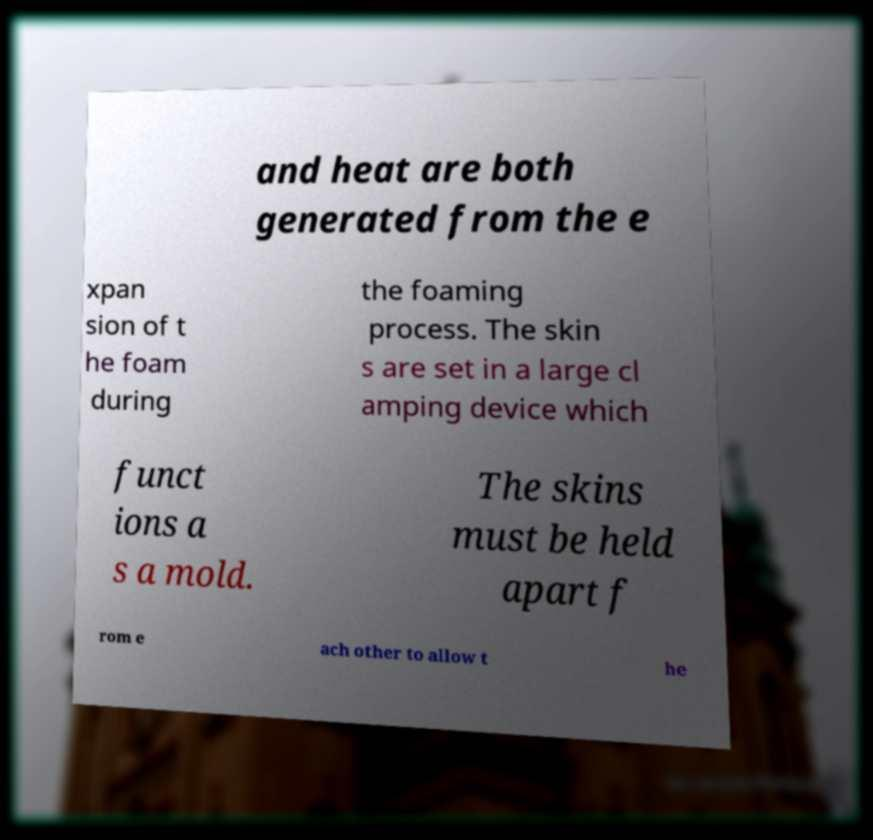Could you assist in decoding the text presented in this image and type it out clearly? and heat are both generated from the e xpan sion of t he foam during the foaming process. The skin s are set in a large cl amping device which funct ions a s a mold. The skins must be held apart f rom e ach other to allow t he 